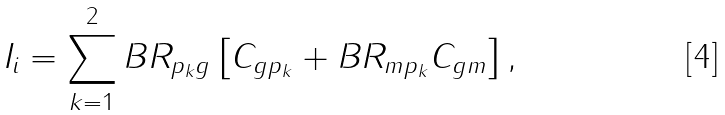<formula> <loc_0><loc_0><loc_500><loc_500>I _ { i } = \sum _ { k = 1 } ^ { 2 } B R _ { p _ { k } g } \left [ C _ { g p _ { k } } + B R _ { m p _ { k } } C _ { g m } \right ] ,</formula> 